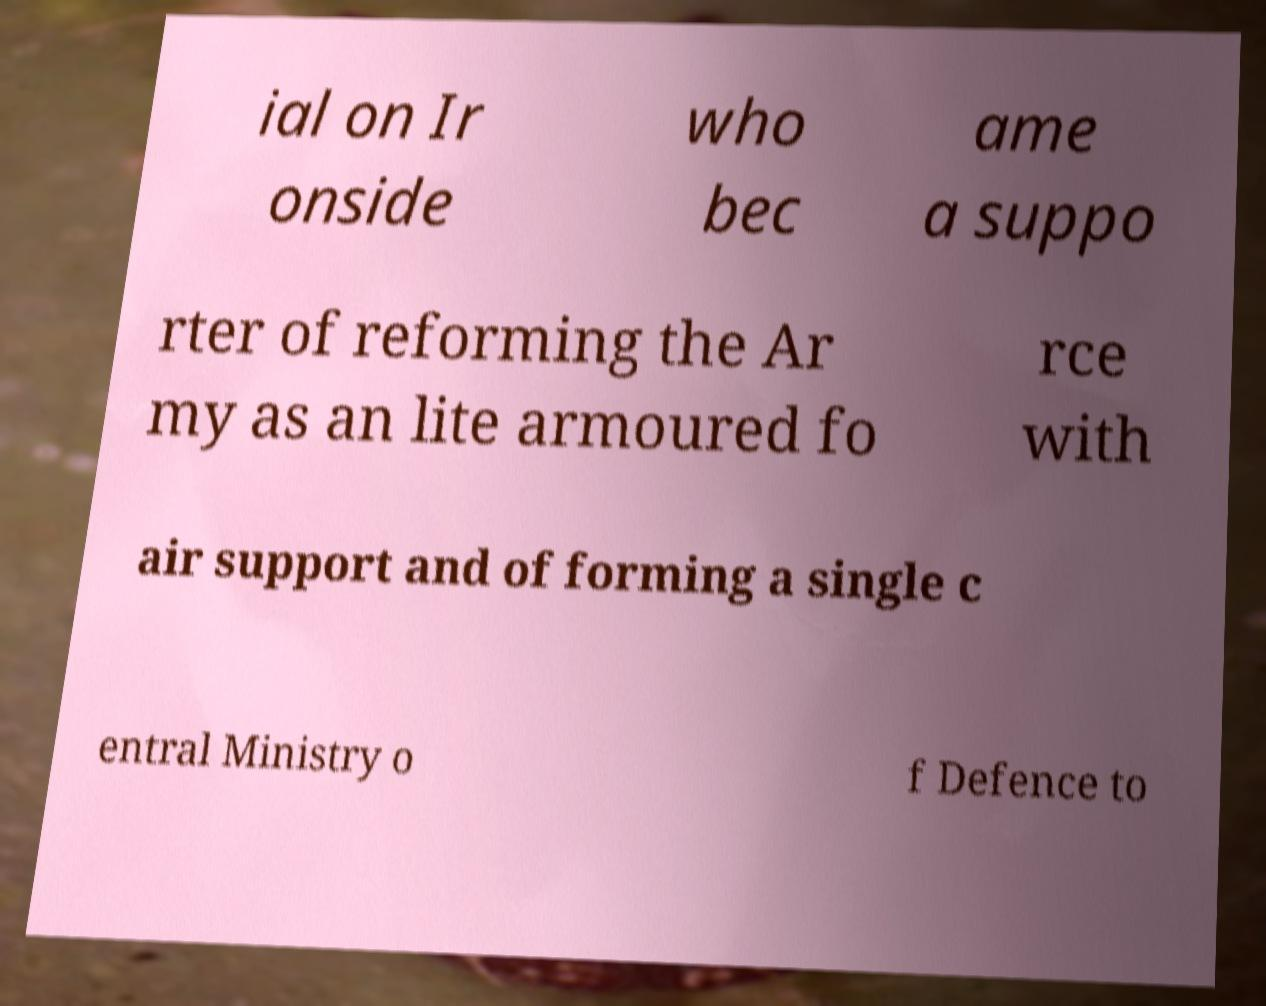There's text embedded in this image that I need extracted. Can you transcribe it verbatim? ial on Ir onside who bec ame a suppo rter of reforming the Ar my as an lite armoured fo rce with air support and of forming a single c entral Ministry o f Defence to 